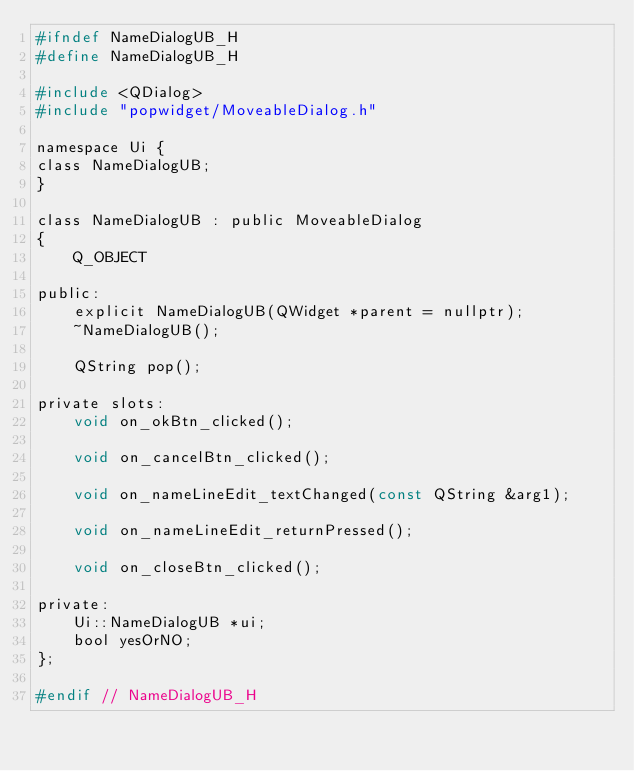<code> <loc_0><loc_0><loc_500><loc_500><_C_>#ifndef NameDialogUB_H
#define NameDialogUB_H

#include <QDialog>
#include "popwidget/MoveableDialog.h"

namespace Ui {
class NameDialogUB;
}

class NameDialogUB : public MoveableDialog
{
    Q_OBJECT

public:
    explicit NameDialogUB(QWidget *parent = nullptr);
    ~NameDialogUB();

    QString pop();

private slots:
    void on_okBtn_clicked();

    void on_cancelBtn_clicked();

    void on_nameLineEdit_textChanged(const QString &arg1);

    void on_nameLineEdit_returnPressed();

    void on_closeBtn_clicked();

private:
    Ui::NameDialogUB *ui;
    bool yesOrNO;
};

#endif // NameDialogUB_H
</code> 